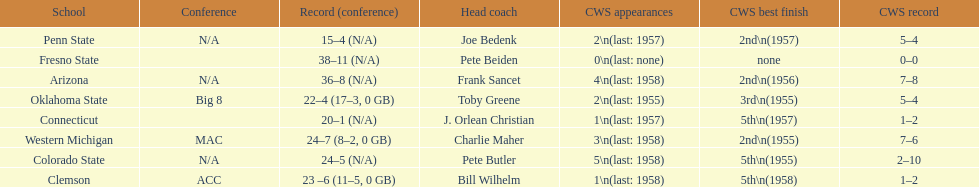Oklahoma state and penn state both have how many cws appearances? 2. 